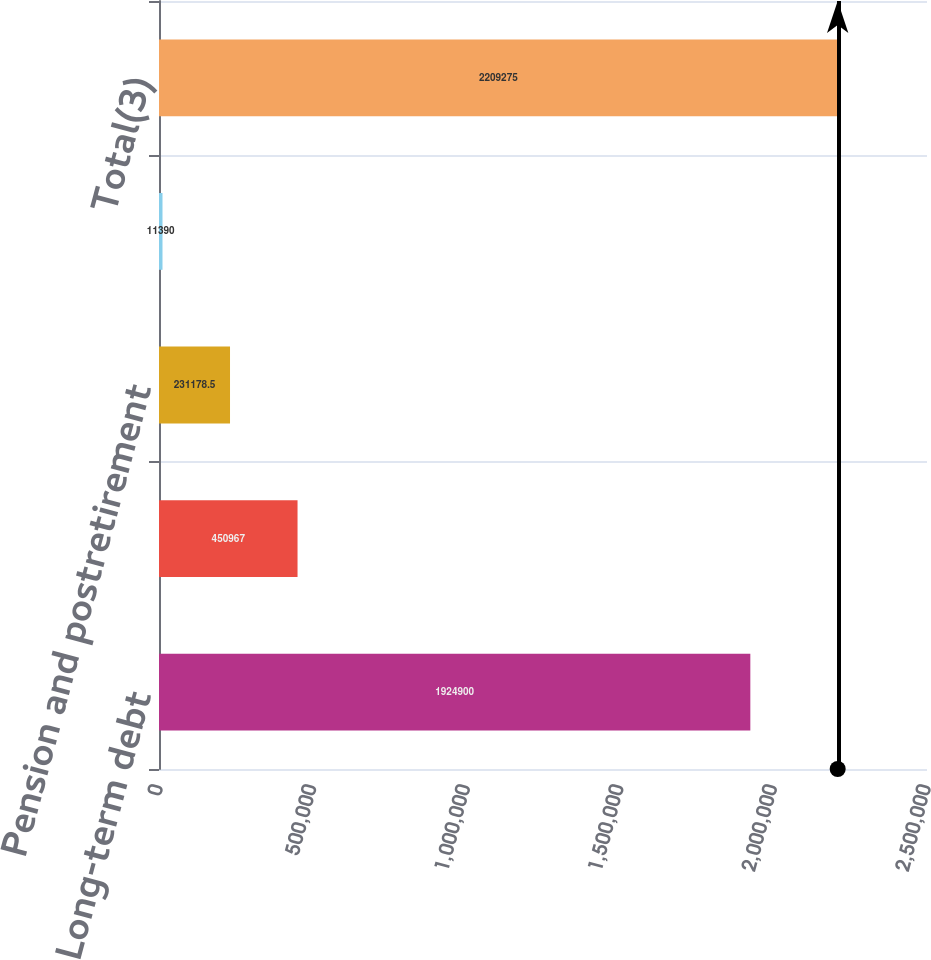Convert chart to OTSL. <chart><loc_0><loc_0><loc_500><loc_500><bar_chart><fcel>Long-term debt<fcel>Operating leases<fcel>Pension and postretirement<fcel>Other long-term liabilities(2)<fcel>Total(3)<nl><fcel>1.9249e+06<fcel>450967<fcel>231178<fcel>11390<fcel>2.20928e+06<nl></chart> 